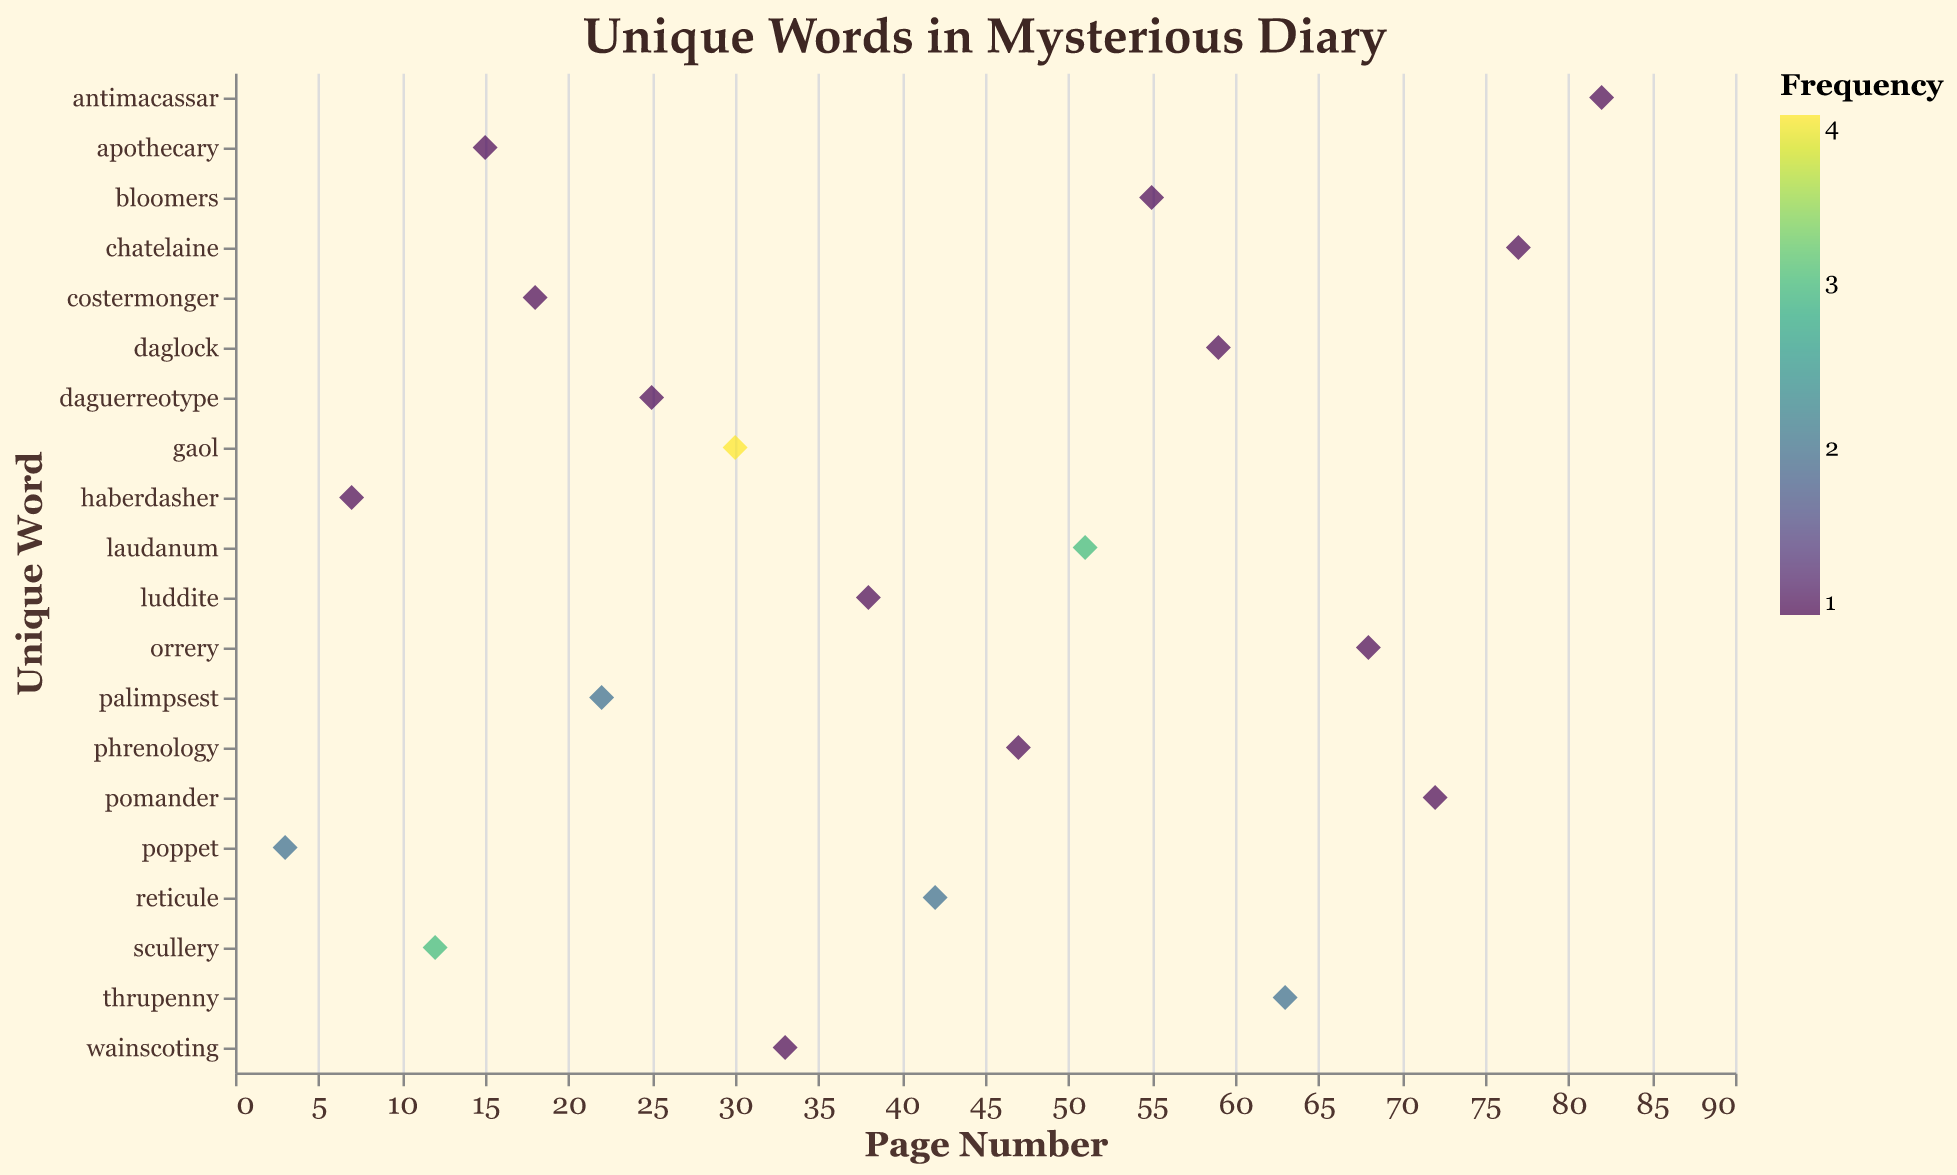what is the title of the figure? The title is prominently displayed at the top of the figure. The exact wording of the title is visible within the plot.
Answer: Unique Words in Mysterious Diary On which page does the word 'scullery' appear? The plot shows unique words on the y-axis and page numbers on the x-axis. By checking the location where 'scullery' aligns with the x-axis, you can find its page number.
Answer: 12 What is the word with the highest frequency, and what is that frequency? The color intensity represents frequency. The word with the highest frequency will have the most intense color. 'Gaol' has the highest frequency, with a value of 4.
Answer: Gaol, 4 How many words appear more than once in the diary? By checking the colors or the values directly in the tooltip, we can count how many unique words have a frequency greater than one. The words are 'poppet', 'scullery', 'palimpsest', 'gaol', 'reticule', 'laudanum', and 'thrupenny'. Count these words.
Answer: 7 Which page contains the word with the smallest frequency? Find the word with the least color intensity indicating a frequency of 1. Then, note the corresponding page number. Many words have a frequency of 1, such as 'haberdasher' on page 7. Any of these words should suffice for the answer.
Answer: 7 (Acceptable: pages with frequency 1) What is the combined frequency of the words on even-numbered pages? Check the frequencies of the words on even-numbered pages (pages: 12, 18, 22, 30, 42, 68, 72) and sum them up. 3 (scullery) + 1 (costermonger) + 2 (palimpsest) + 4 (gaol) + 2 (reticule) + 1 (orrery) + 1 (pomander) is the calculation.
Answer: 14 Are there more words on pages before or after page 40? Count the words on pages 1-39 and compare them with those on pages 40-82. Before page 40: 9 (poppet, haberdasher, scullery, apothecary, costermonger, palimpsest, daguerreotype, gaol, wainscoting). After page 40: 11 (luddite, reticule, phrenology, laudanum, bloomers, daglock, thrupenny, orrery, pomander, chatelaine, antimacassar).
Answer: After page 40 Which unique word appears on the highest and lowest page numbers? The word on the highest page number (82) is 'antimacassar' and on the lowest page number (3) is 'poppet'. Refer to the X-axis values for this determination.
Answer: Highest: antimacassar, Lowest: poppet 